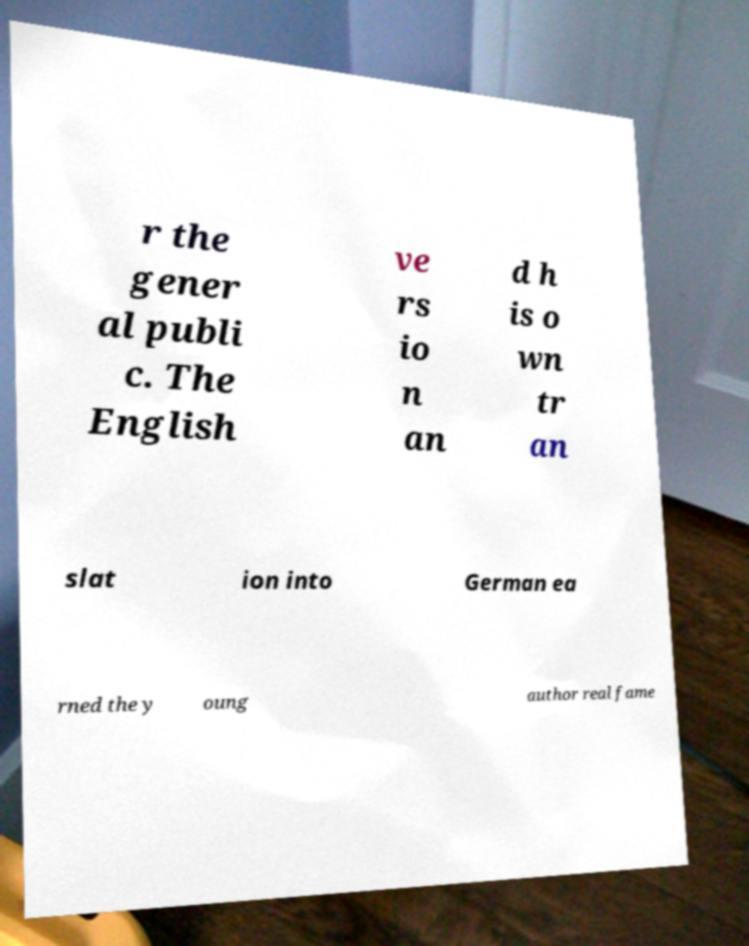I need the written content from this picture converted into text. Can you do that? r the gener al publi c. The English ve rs io n an d h is o wn tr an slat ion into German ea rned the y oung author real fame 